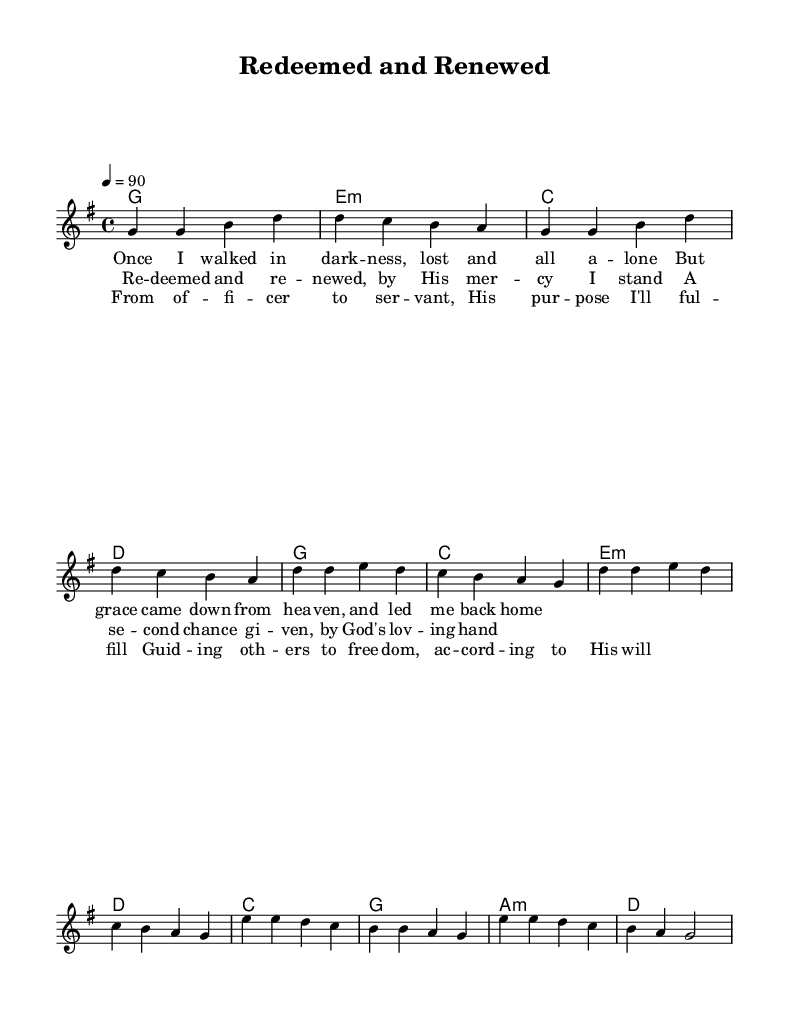What is the key signature of this music? The key signature is G major, which features one sharp (F#). This can be identified in the header specifications for the global context of the score.
Answer: G major What is the time signature of this music? The time signature is 4/4, which indicates four beats per measure and can be found in the global settings of the score.
Answer: 4/4 What is the tempo indication for this piece? The tempo is marked as quarter note equals 90, allowing us to determine the speed of the piece. This information is included in the global settings section of the score.
Answer: 90 How many verses are present in the song? There is one verse, as indicated in the notation of the lyrics section before moving to the chorus and bridge.
Answer: One What is the main theme of this gospel song? The main theme revolves around redemption and second chances, which is conveyed through the lyrics discussing grace, mercy, and transformation. This thematic representation is clear in the text of the lyrics.
Answer: Redemption What musical section follows the verse in this piece? The section that follows the verse is the chorus. This can be deduced from the structure of the song as outlined in the score, where the verse leads directly into the chorus.
Answer: Chorus What role does the bridge serve in this music? The bridge provides a contrast to the preceding sections, adding a new perspective and reinforcing the theme of purpose and guidance, as articulated in its lyrics. This contextual function of the bridge is common in gospel music.
Answer: Contrast 